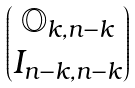Convert formula to latex. <formula><loc_0><loc_0><loc_500><loc_500>\begin{pmatrix} \mathbb { O } _ { k , n - k } \\ I _ { n - k , n - k } \end{pmatrix}</formula> 